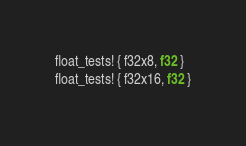Convert code to text. <code><loc_0><loc_0><loc_500><loc_500><_Rust_>float_tests! { f32x8, f32 }
float_tests! { f32x16, f32 }
</code> 